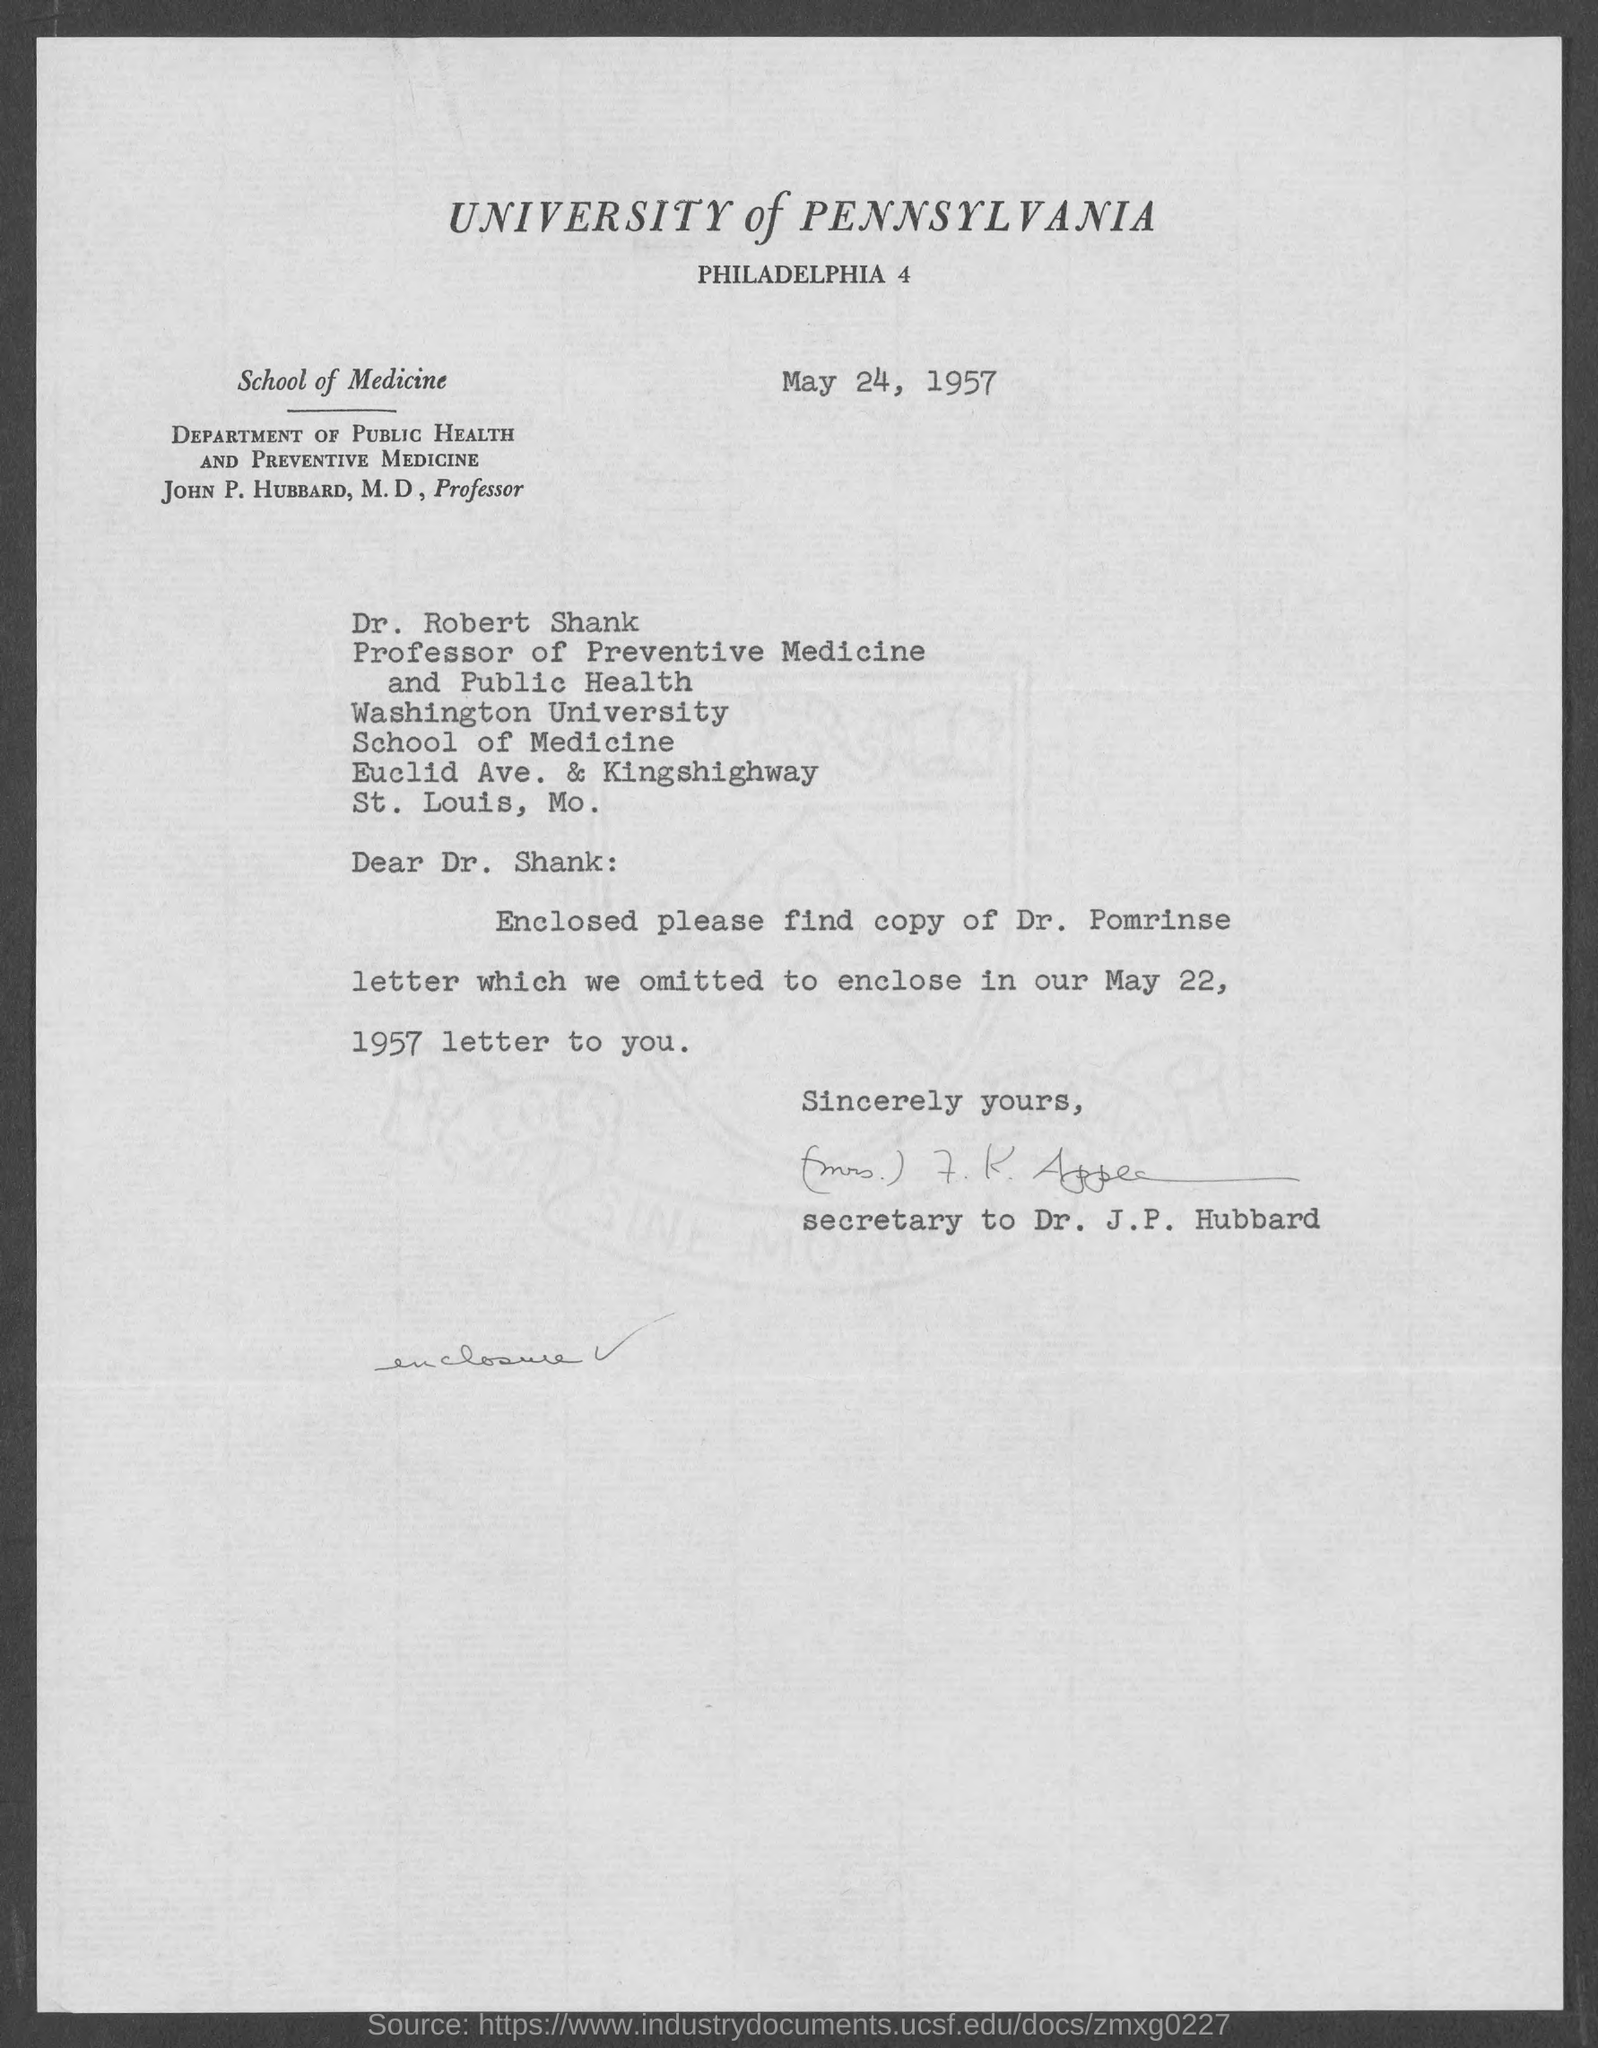Highlight a few significant elements in this photo. The letter is addressed to Dr. Robert Shank. The date on the letter is May 24, 1957. The letter enclosed with this letter is the copy of whose letter?" the person named Dr. Pomrinse is asking. 